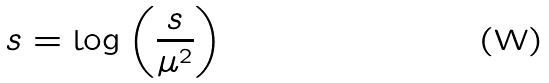Convert formula to latex. <formula><loc_0><loc_0><loc_500><loc_500>\L s = \log \left ( \frac { s } { \mu ^ { 2 } } \right )</formula> 